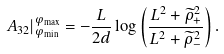<formula> <loc_0><loc_0><loc_500><loc_500>A _ { 3 2 } | _ { \varphi _ { \min } } ^ { \varphi _ { \max } } = - \frac { L } { 2 d } \log \left ( \frac { L ^ { 2 } + \widetilde { \rho } _ { + } ^ { 2 } } { L ^ { 2 } + \widetilde { \rho } _ { - } ^ { 2 } } \right ) .</formula> 